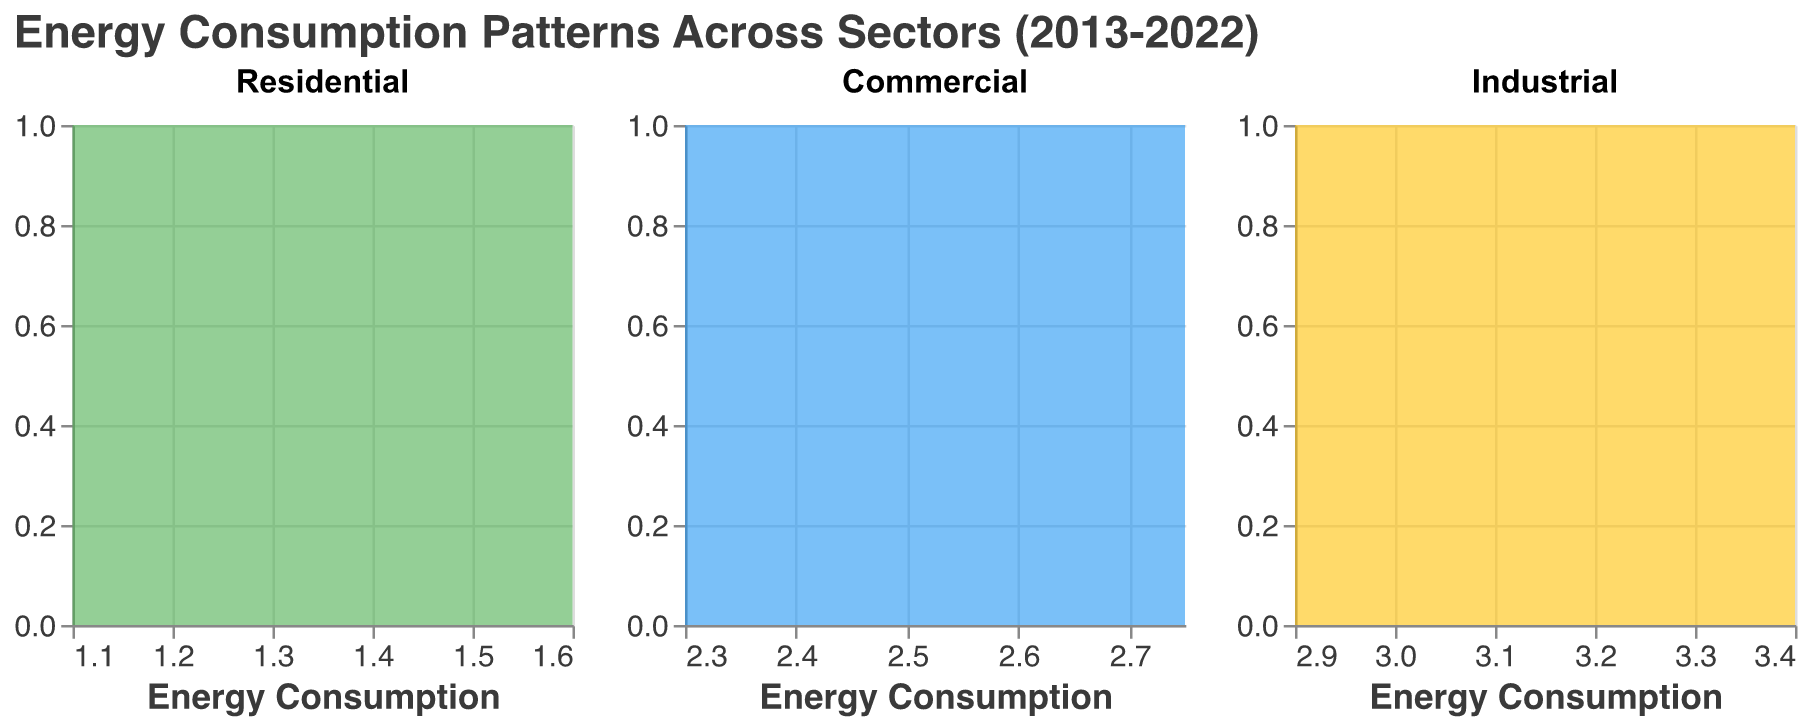What is the title of the figure? Look at the text at the top center of the figure, which usually describes the content of the plot. The title here is indicated clearly.
Answer: "Energy Consumption Patterns Across Sectors (2013-2022)" Which sector has the highest ending energy consumption in 2022? Compare the 2022 data from each sector subplot: Residential (1.6), Commercial (2.75), and Industrial (3.4). The highest figure is for the Industrial sector.
Answer: Industrial What is the color used for the Commercial sector plot? Refer to the color of the area filling for the Commercial sector subplot. It’s shown to have a specific color distinct from the others.
Answer: Blue What is the total number of distinct years displayed in the data? The data spans from 2013 to 2022, inclusive. Count each year from start to end.
Answer: 10 years Which sector shows the steepest increase in energy consumption over the plotted decade? Examine the rate of change in energy consumption over time for each sector, judging from the density plot shapes and trends. The Industrial sector shows the most significant increase in energy consumption.
Answer: Industrial Which sector shows the highest variation in energy consumption over the decade? Check the spread and changes in each sector’s subplot over time. Larger variations will show as more distinct shifts. The Industrial sector has the largest variation in values from 2.9 in 2013 to 3.4 in 2022.
Answer: Industrial In which range do most of the energy consumption values of the Residential sector fall? Examine the density plot of the Residential sector to determine the range where the highest density appears. This range usually is from 1.1 to 1.6
Answer: 1.1 to 1.6 